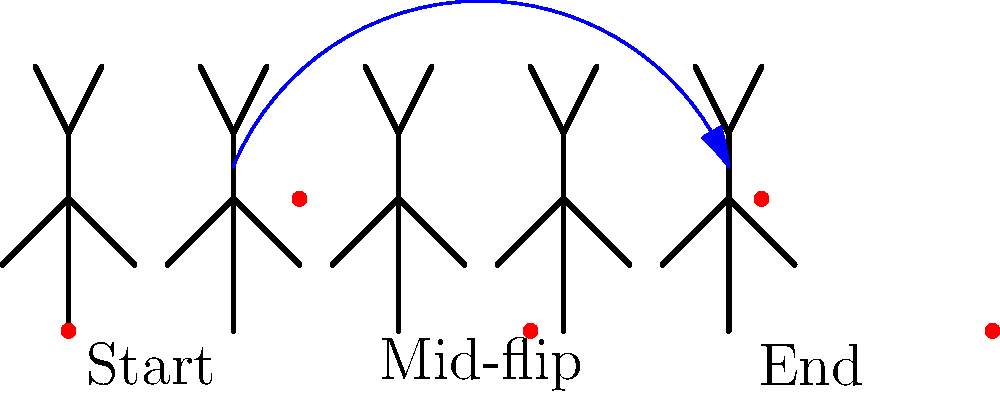In the image above, the red dots represent the center of mass of a gymnast performing a backflip. How does the path of the center of mass relate to the concept of projectile motion in physics, and why might this be significant for a gymnast's performance? To understand the significance of the center of mass path in a gymnast's backflip, let's break it down step-by-step:

1. Center of Mass (COM) Path: The red dots show that the COM follows a smooth, parabolic trajectory.

2. Projectile Motion: This parabolic path is characteristic of projectile motion, which occurs when an object is launched into the air and is only affected by gravity and air resistance.

3. Physics Principle: In projectile motion, the horizontal velocity remains constant (ignoring air resistance), while the vertical velocity changes due to gravity. This results in the parabolic path we observe.

4. Significance for Gymnastics:
   a) Predictability: The COM follows a predictable path, allowing gymnasts to plan their movements precisely.
   b) Efficiency: A smooth COM path indicates efficient use of energy and body control.
   c) Judging Criteria: Judges often look for a "high and long" flip, which is reflected in the COM trajectory.
   d) Safety: Understanding the COM path helps gymnasts land safely by positioning their body correctly.

5. Body Rotation: While the COM follows a simple path, the gymnast's body rotates around this point, creating the flip motion.

6. Initial Velocity: The height and length of the parabola are determined by the initial velocity at takeoff, which the gymnast controls through their jump.

7. Timing: The gymnast must time their body movements to complete the rotation before landing, all while the COM follows its predetermined path.

Understanding this relationship between the COM path and projectile motion allows gymnasts to optimize their performance, improve consistency, and execute complex maneuvers safely.
Answer: The center of mass follows a parabolic path characteristic of projectile motion, allowing gymnasts to predict and control their movement for optimal performance and safety. 